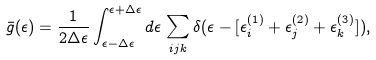Convert formula to latex. <formula><loc_0><loc_0><loc_500><loc_500>\bar { g } ( \epsilon ) = \frac { 1 } { 2 \Delta \epsilon } \int _ { \epsilon - \Delta \epsilon } ^ { \epsilon + \Delta \epsilon } d \epsilon \, \sum _ { i j k } \delta ( \epsilon - [ \epsilon _ { i } ^ { ( 1 ) } + \epsilon _ { j } ^ { ( 2 ) } + \epsilon _ { k } ^ { ( 3 ) } ] ) ,</formula> 